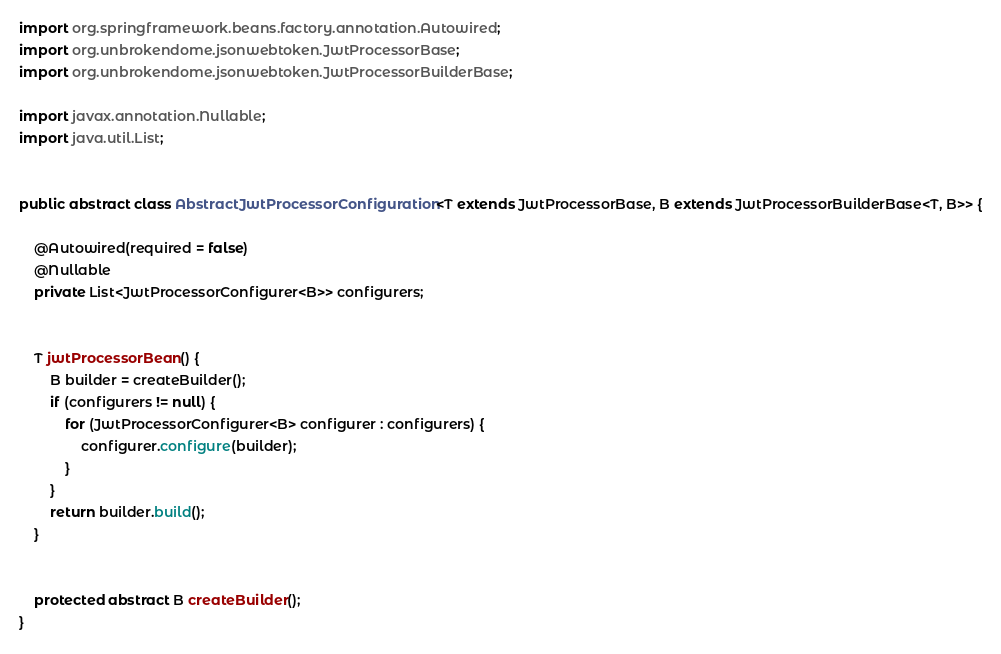Convert code to text. <code><loc_0><loc_0><loc_500><loc_500><_Java_>
import org.springframework.beans.factory.annotation.Autowired;
import org.unbrokendome.jsonwebtoken.JwtProcessorBase;
import org.unbrokendome.jsonwebtoken.JwtProcessorBuilderBase;

import javax.annotation.Nullable;
import java.util.List;


public abstract class AbstractJwtProcessorConfiguration<T extends JwtProcessorBase, B extends JwtProcessorBuilderBase<T, B>> {

    @Autowired(required = false)
    @Nullable
    private List<JwtProcessorConfigurer<B>> configurers;


    T jwtProcessorBean() {
        B builder = createBuilder();
        if (configurers != null) {
            for (JwtProcessorConfigurer<B> configurer : configurers) {
                configurer.configure(builder);
            }
        }
        return builder.build();
    }


    protected abstract B createBuilder();
}
</code> 